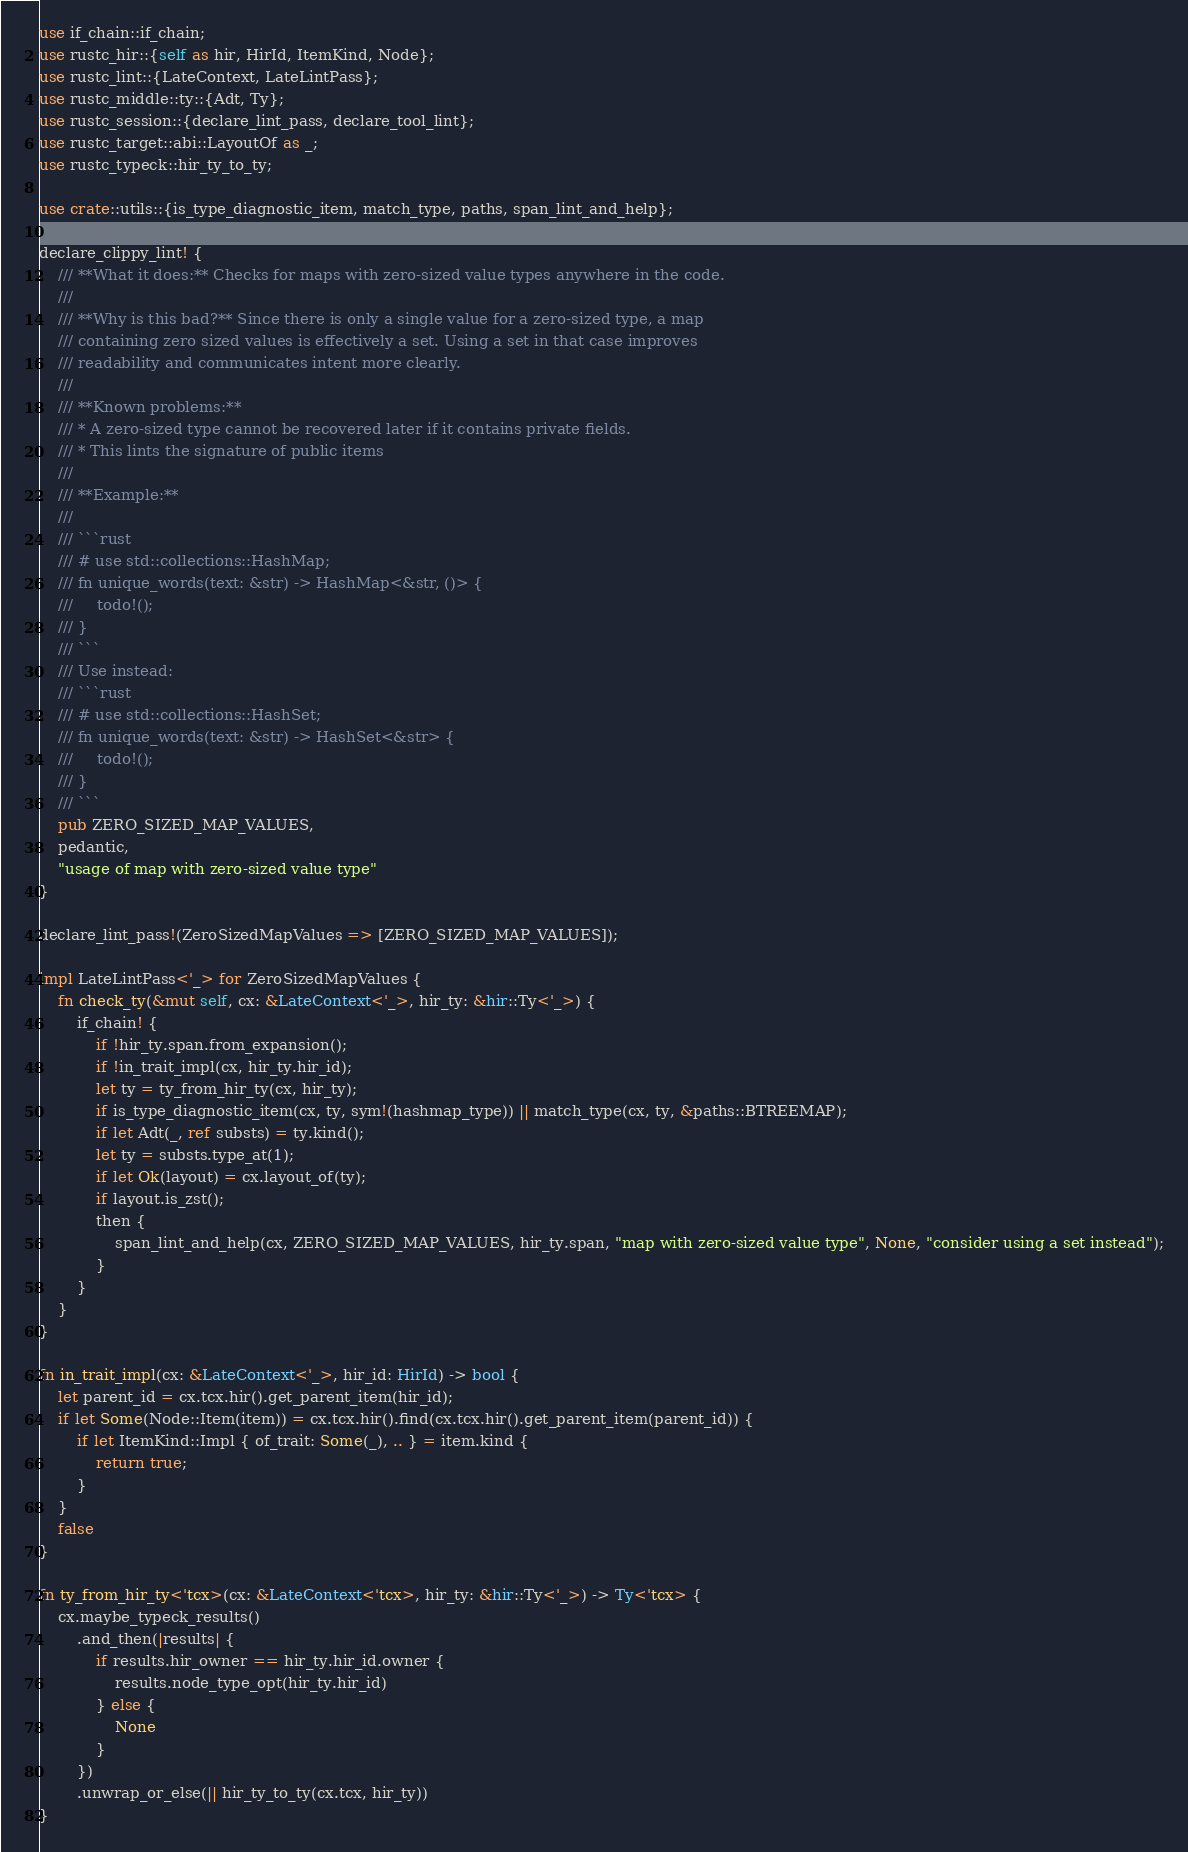<code> <loc_0><loc_0><loc_500><loc_500><_Rust_>use if_chain::if_chain;
use rustc_hir::{self as hir, HirId, ItemKind, Node};
use rustc_lint::{LateContext, LateLintPass};
use rustc_middle::ty::{Adt, Ty};
use rustc_session::{declare_lint_pass, declare_tool_lint};
use rustc_target::abi::LayoutOf as _;
use rustc_typeck::hir_ty_to_ty;

use crate::utils::{is_type_diagnostic_item, match_type, paths, span_lint_and_help};

declare_clippy_lint! {
    /// **What it does:** Checks for maps with zero-sized value types anywhere in the code.
    ///
    /// **Why is this bad?** Since there is only a single value for a zero-sized type, a map
    /// containing zero sized values is effectively a set. Using a set in that case improves
    /// readability and communicates intent more clearly.
    ///
    /// **Known problems:**
    /// * A zero-sized type cannot be recovered later if it contains private fields.
    /// * This lints the signature of public items
    ///
    /// **Example:**
    ///
    /// ```rust
    /// # use std::collections::HashMap;
    /// fn unique_words(text: &str) -> HashMap<&str, ()> {
    ///     todo!();
    /// }
    /// ```
    /// Use instead:
    /// ```rust
    /// # use std::collections::HashSet;
    /// fn unique_words(text: &str) -> HashSet<&str> {
    ///     todo!();
    /// }
    /// ```
    pub ZERO_SIZED_MAP_VALUES,
    pedantic,
    "usage of map with zero-sized value type"
}

declare_lint_pass!(ZeroSizedMapValues => [ZERO_SIZED_MAP_VALUES]);

impl LateLintPass<'_> for ZeroSizedMapValues {
    fn check_ty(&mut self, cx: &LateContext<'_>, hir_ty: &hir::Ty<'_>) {
        if_chain! {
            if !hir_ty.span.from_expansion();
            if !in_trait_impl(cx, hir_ty.hir_id);
            let ty = ty_from_hir_ty(cx, hir_ty);
            if is_type_diagnostic_item(cx, ty, sym!(hashmap_type)) || match_type(cx, ty, &paths::BTREEMAP);
            if let Adt(_, ref substs) = ty.kind();
            let ty = substs.type_at(1);
            if let Ok(layout) = cx.layout_of(ty);
            if layout.is_zst();
            then {
                span_lint_and_help(cx, ZERO_SIZED_MAP_VALUES, hir_ty.span, "map with zero-sized value type", None, "consider using a set instead");
            }
        }
    }
}

fn in_trait_impl(cx: &LateContext<'_>, hir_id: HirId) -> bool {
    let parent_id = cx.tcx.hir().get_parent_item(hir_id);
    if let Some(Node::Item(item)) = cx.tcx.hir().find(cx.tcx.hir().get_parent_item(parent_id)) {
        if let ItemKind::Impl { of_trait: Some(_), .. } = item.kind {
            return true;
        }
    }
    false
}

fn ty_from_hir_ty<'tcx>(cx: &LateContext<'tcx>, hir_ty: &hir::Ty<'_>) -> Ty<'tcx> {
    cx.maybe_typeck_results()
        .and_then(|results| {
            if results.hir_owner == hir_ty.hir_id.owner {
                results.node_type_opt(hir_ty.hir_id)
            } else {
                None
            }
        })
        .unwrap_or_else(|| hir_ty_to_ty(cx.tcx, hir_ty))
}
</code> 